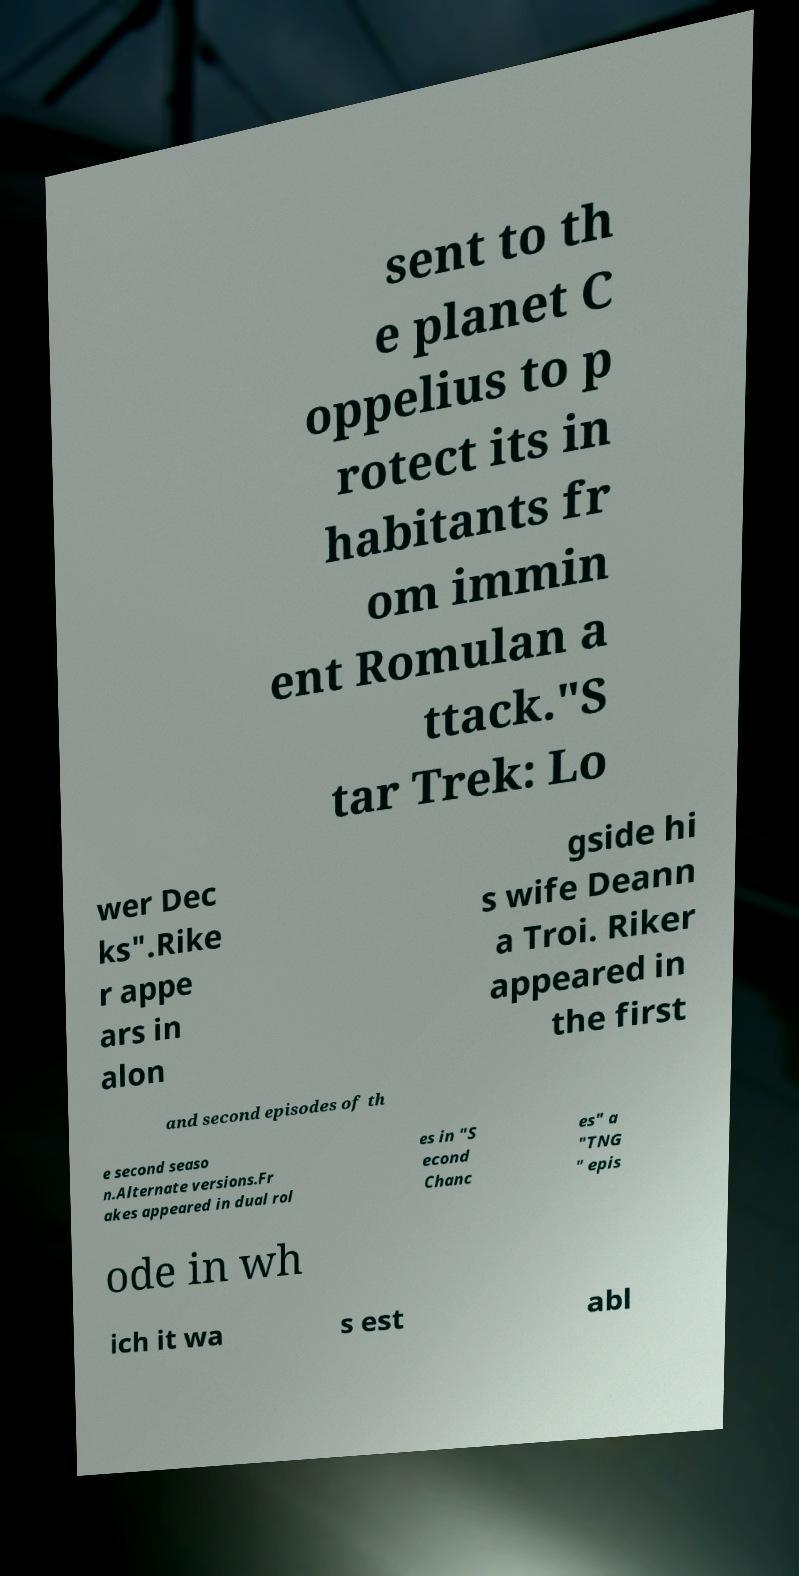I need the written content from this picture converted into text. Can you do that? sent to th e planet C oppelius to p rotect its in habitants fr om immin ent Romulan a ttack."S tar Trek: Lo wer Dec ks".Rike r appe ars in alon gside hi s wife Deann a Troi. Riker appeared in the first and second episodes of th e second seaso n.Alternate versions.Fr akes appeared in dual rol es in "S econd Chanc es" a "TNG " epis ode in wh ich it wa s est abl 